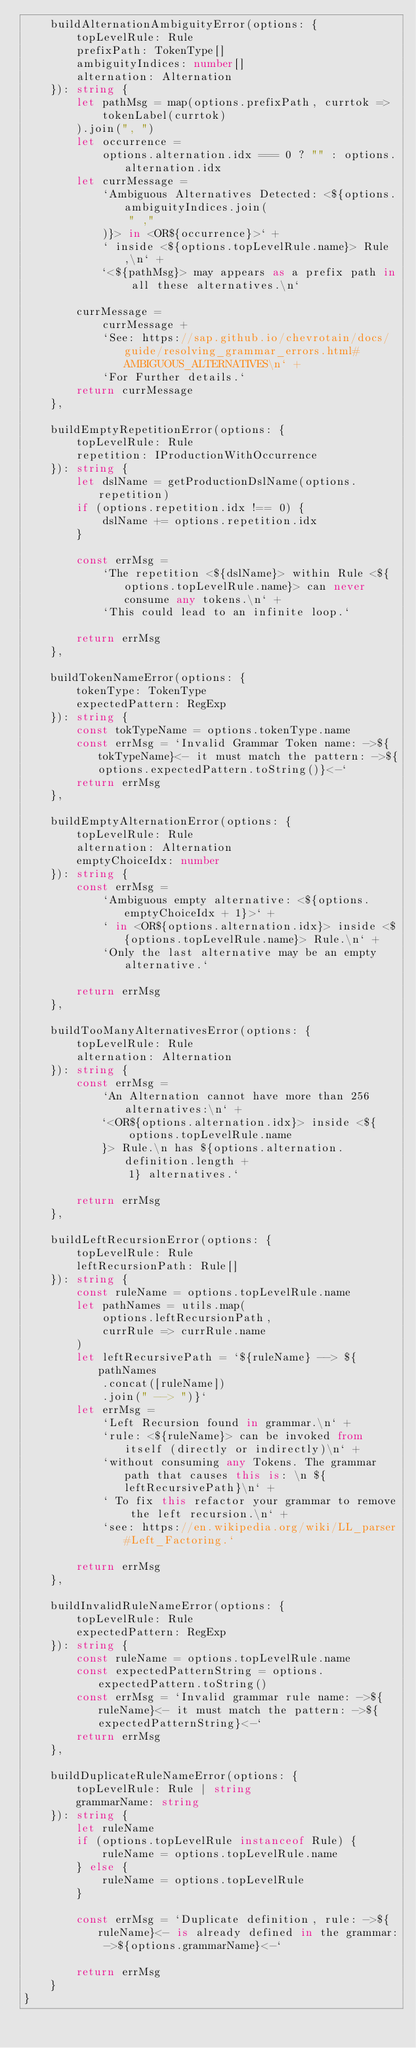Convert code to text. <code><loc_0><loc_0><loc_500><loc_500><_TypeScript_>    buildAlternationAmbiguityError(options: {
        topLevelRule: Rule
        prefixPath: TokenType[]
        ambiguityIndices: number[]
        alternation: Alternation
    }): string {
        let pathMsg = map(options.prefixPath, currtok =>
            tokenLabel(currtok)
        ).join(", ")
        let occurrence =
            options.alternation.idx === 0 ? "" : options.alternation.idx
        let currMessage =
            `Ambiguous Alternatives Detected: <${options.ambiguityIndices.join(
                " ,"
            )}> in <OR${occurrence}>` +
            ` inside <${options.topLevelRule.name}> Rule,\n` +
            `<${pathMsg}> may appears as a prefix path in all these alternatives.\n`

        currMessage =
            currMessage +
            `See: https://sap.github.io/chevrotain/docs/guide/resolving_grammar_errors.html#AMBIGUOUS_ALTERNATIVES\n` +
            `For Further details.`
        return currMessage
    },

    buildEmptyRepetitionError(options: {
        topLevelRule: Rule
        repetition: IProductionWithOccurrence
    }): string {
        let dslName = getProductionDslName(options.repetition)
        if (options.repetition.idx !== 0) {
            dslName += options.repetition.idx
        }

        const errMsg =
            `The repetition <${dslName}> within Rule <${options.topLevelRule.name}> can never consume any tokens.\n` +
            `This could lead to an infinite loop.`

        return errMsg
    },

    buildTokenNameError(options: {
        tokenType: TokenType
        expectedPattern: RegExp
    }): string {
        const tokTypeName = options.tokenType.name
        const errMsg = `Invalid Grammar Token name: ->${tokTypeName}<- it must match the pattern: ->${options.expectedPattern.toString()}<-`
        return errMsg
    },

    buildEmptyAlternationError(options: {
        topLevelRule: Rule
        alternation: Alternation
        emptyChoiceIdx: number
    }): string {
        const errMsg =
            `Ambiguous empty alternative: <${options.emptyChoiceIdx + 1}>` +
            ` in <OR${options.alternation.idx}> inside <${options.topLevelRule.name}> Rule.\n` +
            `Only the last alternative may be an empty alternative.`

        return errMsg
    },

    buildTooManyAlternativesError(options: {
        topLevelRule: Rule
        alternation: Alternation
    }): string {
        const errMsg =
            `An Alternation cannot have more than 256 alternatives:\n` +
            `<OR${options.alternation.idx}> inside <${
                options.topLevelRule.name
            }> Rule.\n has ${options.alternation.definition.length +
                1} alternatives.`

        return errMsg
    },

    buildLeftRecursionError(options: {
        topLevelRule: Rule
        leftRecursionPath: Rule[]
    }): string {
        const ruleName = options.topLevelRule.name
        let pathNames = utils.map(
            options.leftRecursionPath,
            currRule => currRule.name
        )
        let leftRecursivePath = `${ruleName} --> ${pathNames
            .concat([ruleName])
            .join(" --> ")}`
        let errMsg =
            `Left Recursion found in grammar.\n` +
            `rule: <${ruleName}> can be invoked from itself (directly or indirectly)\n` +
            `without consuming any Tokens. The grammar path that causes this is: \n ${leftRecursivePath}\n` +
            ` To fix this refactor your grammar to remove the left recursion.\n` +
            `see: https://en.wikipedia.org/wiki/LL_parser#Left_Factoring.`

        return errMsg
    },

    buildInvalidRuleNameError(options: {
        topLevelRule: Rule
        expectedPattern: RegExp
    }): string {
        const ruleName = options.topLevelRule.name
        const expectedPatternString = options.expectedPattern.toString()
        const errMsg = `Invalid grammar rule name: ->${ruleName}<- it must match the pattern: ->${expectedPatternString}<-`
        return errMsg
    },

    buildDuplicateRuleNameError(options: {
        topLevelRule: Rule | string
        grammarName: string
    }): string {
        let ruleName
        if (options.topLevelRule instanceof Rule) {
            ruleName = options.topLevelRule.name
        } else {
            ruleName = options.topLevelRule
        }

        const errMsg = `Duplicate definition, rule: ->${ruleName}<- is already defined in the grammar: ->${options.grammarName}<-`

        return errMsg
    }
}
</code> 